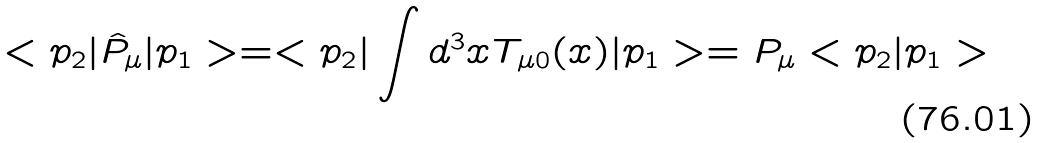Convert formula to latex. <formula><loc_0><loc_0><loc_500><loc_500>< p _ { 2 } | \hat { P } _ { \mu } | p _ { 1 } > = < p _ { 2 } | \int d ^ { 3 } x T _ { \mu 0 } ( x ) | p _ { 1 } > = P _ { \mu } < p _ { 2 } | p _ { 1 } ></formula> 